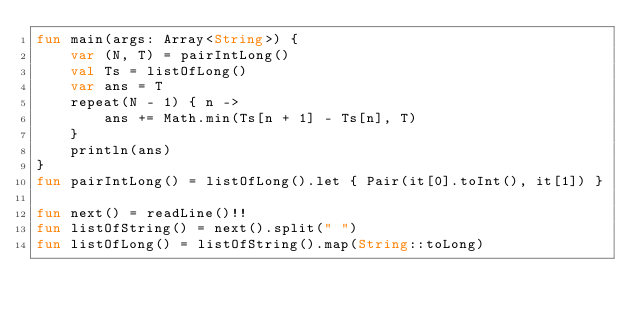Convert code to text. <code><loc_0><loc_0><loc_500><loc_500><_Kotlin_>fun main(args: Array<String>) {
    var (N, T) = pairIntLong()
    val Ts = listOfLong()
    var ans = T
    repeat(N - 1) { n ->
        ans += Math.min(Ts[n + 1] - Ts[n], T)
    }
    println(ans)
}
fun pairIntLong() = listOfLong().let { Pair(it[0].toInt(), it[1]) }

fun next() = readLine()!!
fun listOfString() = next().split(" ")
fun listOfLong() = listOfString().map(String::toLong)
</code> 